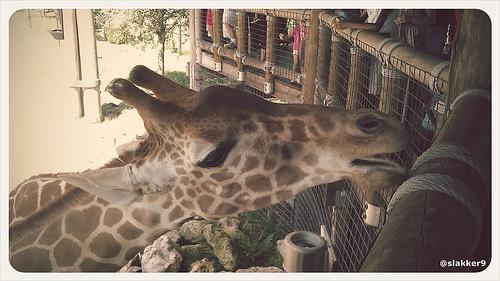How many giraffes are there?
Give a very brief answer. 1. How many horns does the giraffe have?
Give a very brief answer. 2. 